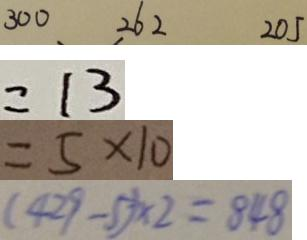Convert formula to latex. <formula><loc_0><loc_0><loc_500><loc_500>3 0 0 、 2 6 2 2 0 5 
 = 1 3 
 = 5 \times 1 0 
 ( 4 2 9 - 5 ) \times 2 = 8 4 8</formula> 